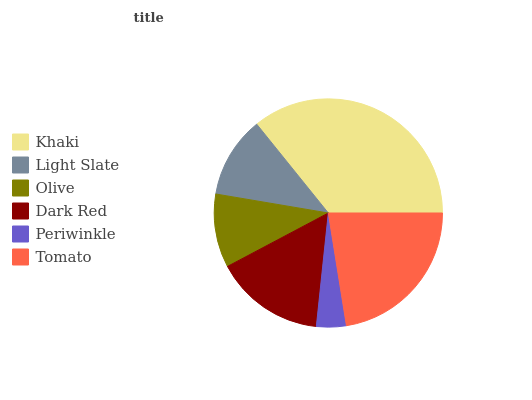Is Periwinkle the minimum?
Answer yes or no. Yes. Is Khaki the maximum?
Answer yes or no. Yes. Is Light Slate the minimum?
Answer yes or no. No. Is Light Slate the maximum?
Answer yes or no. No. Is Khaki greater than Light Slate?
Answer yes or no. Yes. Is Light Slate less than Khaki?
Answer yes or no. Yes. Is Light Slate greater than Khaki?
Answer yes or no. No. Is Khaki less than Light Slate?
Answer yes or no. No. Is Dark Red the high median?
Answer yes or no. Yes. Is Light Slate the low median?
Answer yes or no. Yes. Is Periwinkle the high median?
Answer yes or no. No. Is Periwinkle the low median?
Answer yes or no. No. 